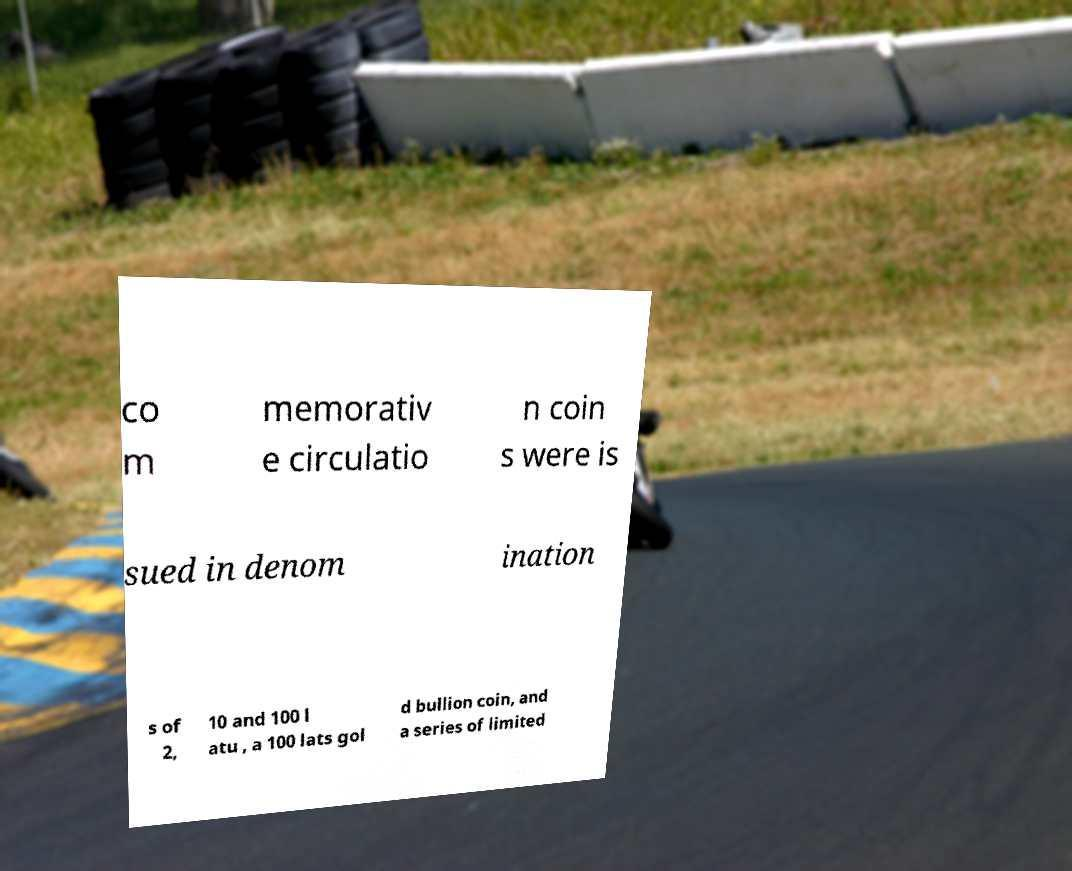For documentation purposes, I need the text within this image transcribed. Could you provide that? co m memorativ e circulatio n coin s were is sued in denom ination s of 2, 10 and 100 l atu , a 100 lats gol d bullion coin, and a series of limited 